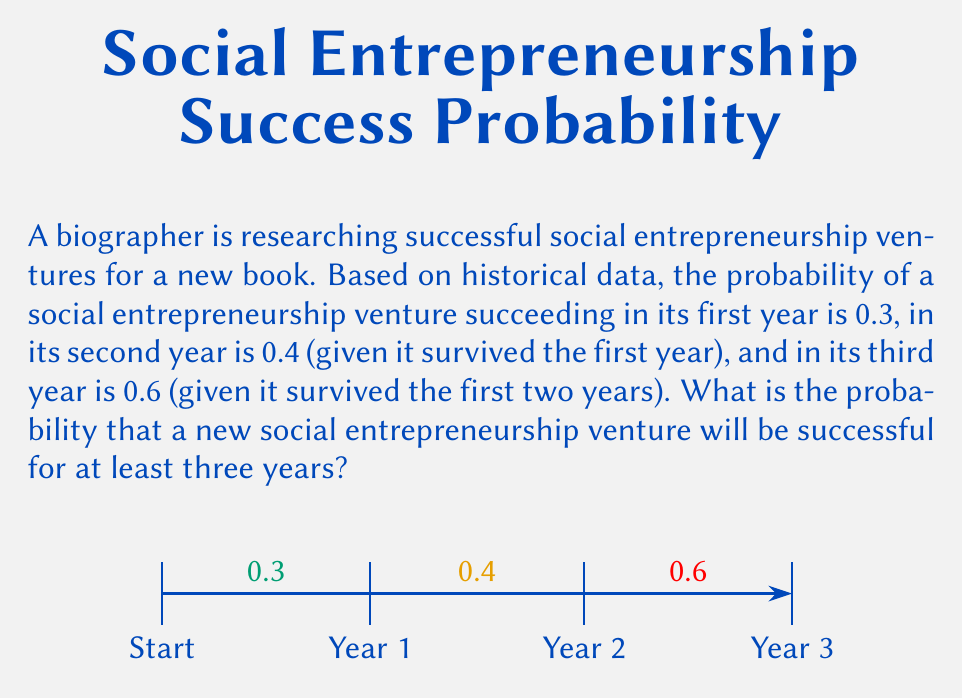Provide a solution to this math problem. To solve this problem, we need to calculate the probability of a venture succeeding in all three years consecutively. We can use the multiplication rule of probability for independent events.

Step 1: Identify the probabilities for each year
- Year 1 success probability: $P(Y1) = 0.3$
- Year 2 success probability (given Year 1 success): $P(Y2|Y1) = 0.4$
- Year 3 success probability (given Year 1 and 2 success): $P(Y3|Y1,Y2) = 0.6$

Step 2: Calculate the joint probability
The probability of succeeding in all three years is the product of these individual probabilities:

$$P(\text{3-year success}) = P(Y1) \times P(Y2|Y1) \times P(Y3|Y1,Y2)$$

Step 3: Substitute the values and compute
$$P(\text{3-year success}) = 0.3 \times 0.4 \times 0.6$$

Step 4: Perform the multiplication
$$P(\text{3-year success}) = 0.072$$

Therefore, the probability that a new social entrepreneurship venture will be successful for at least three years is 0.072 or 7.2%.
Answer: 0.072 